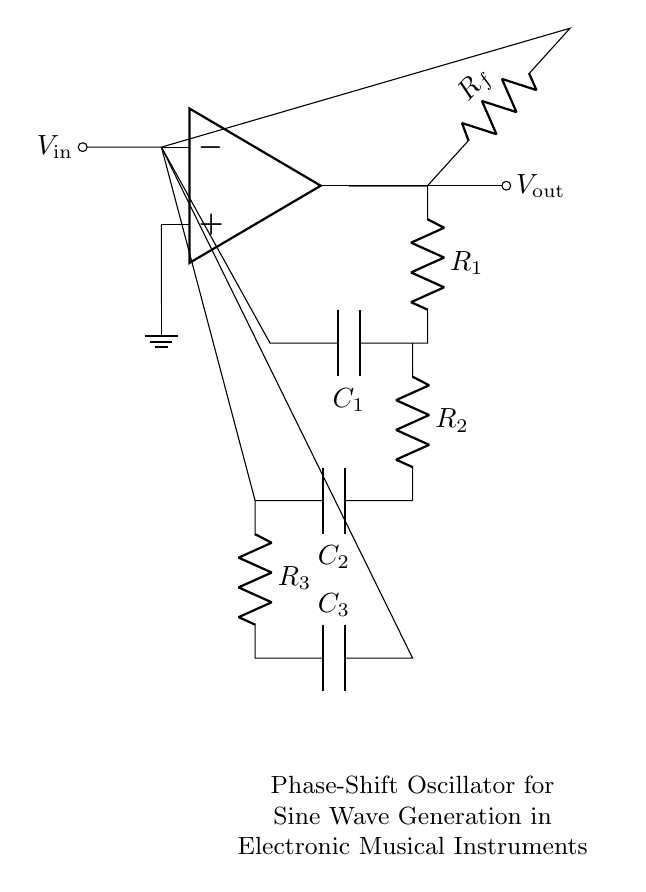What is the input voltage of the circuit? The circuit shows a node labeled "V_in" connected to the inverting input of the operational amplifier, indicating it is the input voltage.
Answer: V_in What type of components are R_f, R_1, R_2, R_3, C_1, C_2, and C_3? The components labeled R_f, R_1, R_2, R_3 are resistors, and C_1, C_2, C_3 are capacitors, as per standard circuit notation.
Answer: Resistors and capacitors How many resistors are in the circuit? By inspecting the labels of the components, there are three resistors: R_f, R_1, and R_2 — R_3 is also a resistor making it a total of four.
Answer: Four What role do the capacitors have in this oscillator circuit? Capacitors in phase-shift oscillator circuits are essential for creating the necessary phase shift. In this diagram, C_1, C_2, and C_3 contribute to the total phase shift required for oscillation.
Answer: Phase shifting What is the significance of the operational amplifier in this circuit? The operational amplifier serves as a voltage amplification device; it is the core element that facilitates feedback and enables the generation of oscillations by maintaining a consistent output waveform.
Answer: Generating oscillations What kind of wave does this oscillator generate? Based on the context and purpose of the circuit, which includes its components and design, it generates sine waves commonly used in electronic musical instruments.
Answer: Sine waves How are the resistors and capacitors connected in the circuit? The components are connected in such a way that they form a feedback loop through the op-amp; they are arranged to create the required phase shifts necessary for oscillation.
Answer: In feedback configuration 